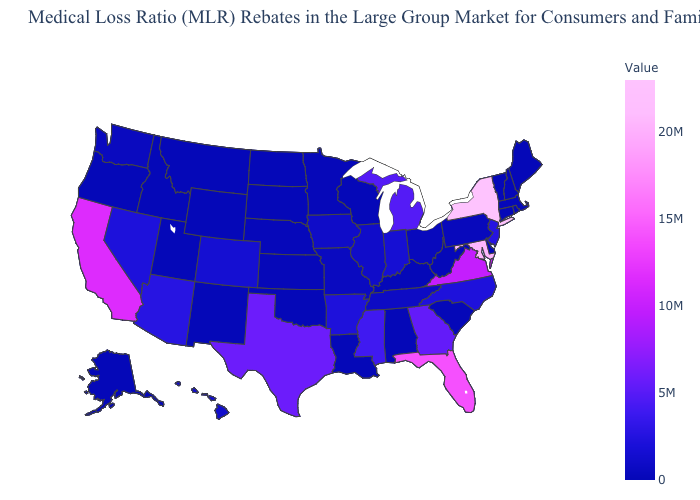Which states hav the highest value in the Northeast?
Be succinct. New York. Which states hav the highest value in the Northeast?
Keep it brief. New York. Which states have the lowest value in the USA?
Quick response, please. Alabama, Alaska, Connecticut, Delaware, Idaho, Kentucky, Louisiana, Maine, Montana, New Hampshire, New Mexico, North Dakota, Oklahoma, Oregon, Rhode Island, South Carolina, South Dakota, Utah, Vermont, Wisconsin, Wyoming. 